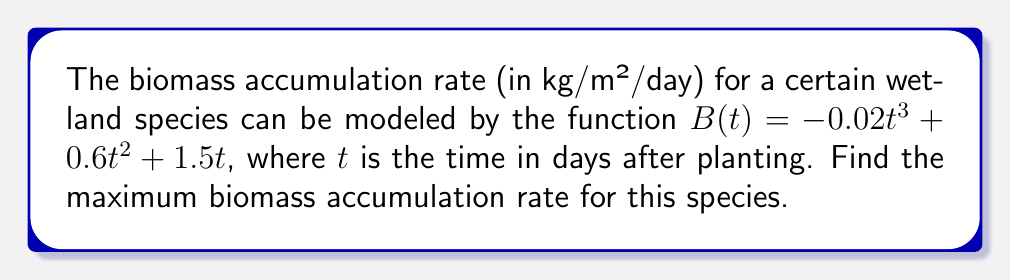Can you answer this question? To find the maximum biomass accumulation rate, we need to follow these steps:

1) First, we need to find the derivative of $B(t)$ with respect to $t$. This will give us the rate of change of biomass accumulation:

   $B'(t) = -0.06t^2 + 1.2t + 1.5$

2) The maximum rate occurs at the point where the derivative of $B'(t)$ equals zero. So, we need to find the second derivative and set it to zero:

   $B''(t) = -0.12t + 1.2$

3) Set $B''(t) = 0$ and solve for $t$:

   $-0.12t + 1.2 = 0$
   $-0.12t = -1.2$
   $t = 10$

4) To confirm this is a maximum (not a minimum), we can check that $B'''(t) = -0.12 < 0$, which indicates concavity down.

5) Now that we know the time at which the maximum rate occurs, we can substitute $t = 10$ back into $B'(t)$ to find the maximum rate:

   $B'(10) = -0.06(10)^2 + 1.2(10) + 1.5$
           $= -6 + 12 + 1.5$
           $= 7.5$

Therefore, the maximum biomass accumulation rate is 7.5 kg/m²/day.
Answer: 7.5 kg/m²/day 